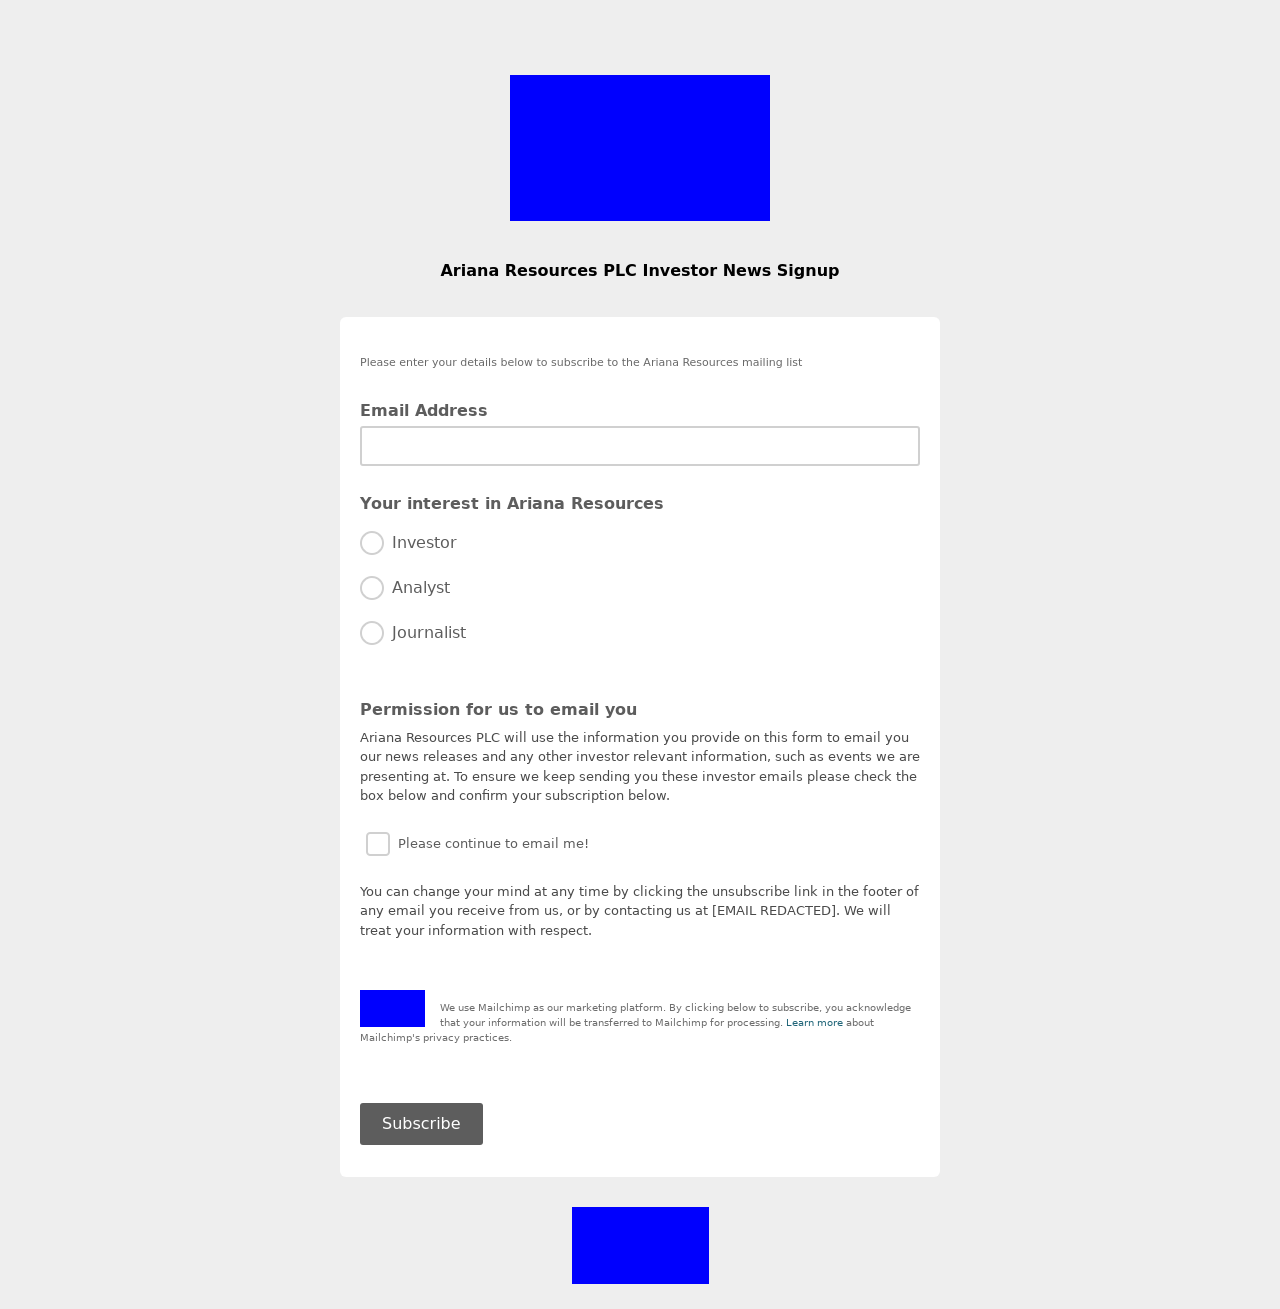Could you guide me through the process of developing this website with HTML? To get started with developing a website similar to the one displayed in the image, begin by setting up the basic structure of your HTML. Start with defining the DOCTYPE and creating the HTML structure with 'head' and 'body' sections. Inside the 'head', include meta tags for responsiveness and character set as well as the 'title' for your webpage. In the 'body', start by structuring your form, which appears to have fields for 'Email Address', 'Your Interest in Ariana Resources', and 'Permission for us to email you'. For each input and label, use appropriate tags such as <input> for user inputs and <label> for descriptions. After setting up the form, ensure to style your webpage using CSS for better user experience. Continuously test your site to ensure it works well across different browsers and devices. 